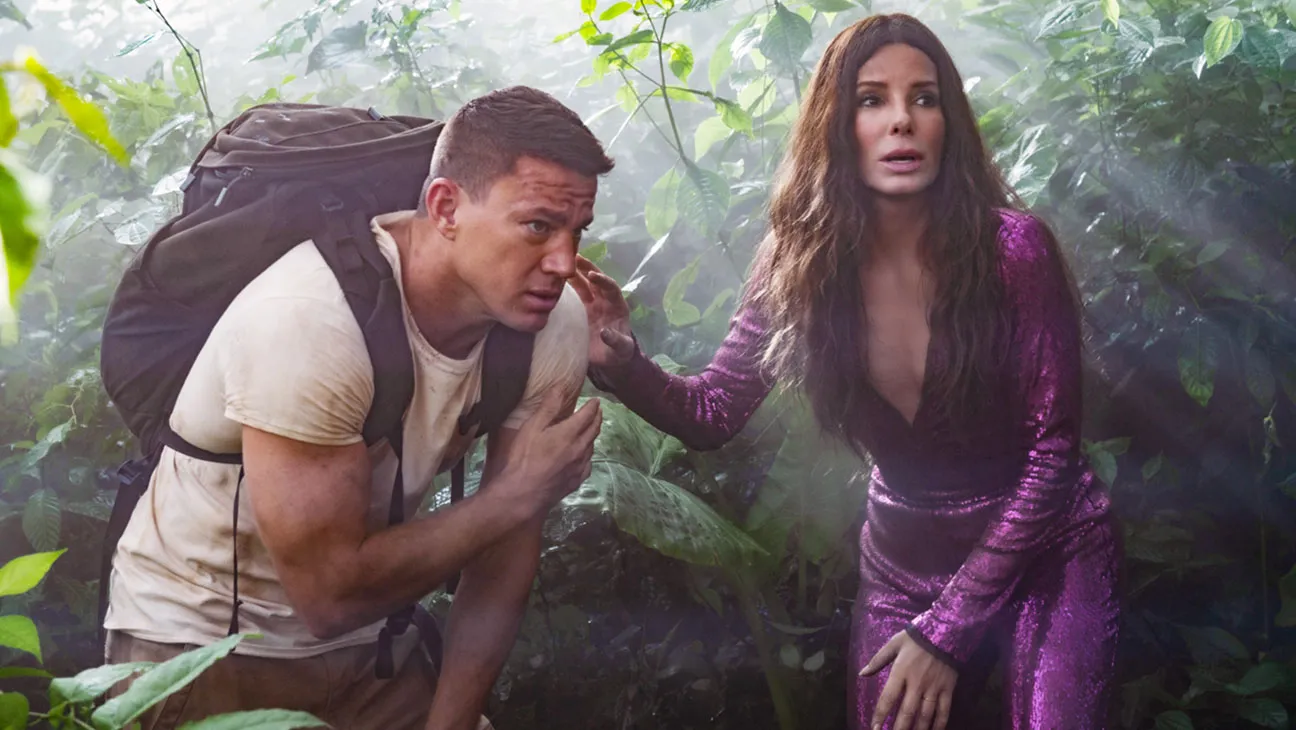What is this photo about? The image shows a scene with actors Sandra Bullock and Channing Tatum, possibly from the film 'The Lost City of D'. Both are deeply immersed in their roles, portrayed in a jungle environment. Sandra, in a striking purple dress, appears tense and concerned, while Channing, in a casual beige outfit with a backpack, looks equally worried. This setup suggests they are navigating a challenging or perilous part of their adventure, emphasizing themes of survival and exploration in a dense, exotic locale. 